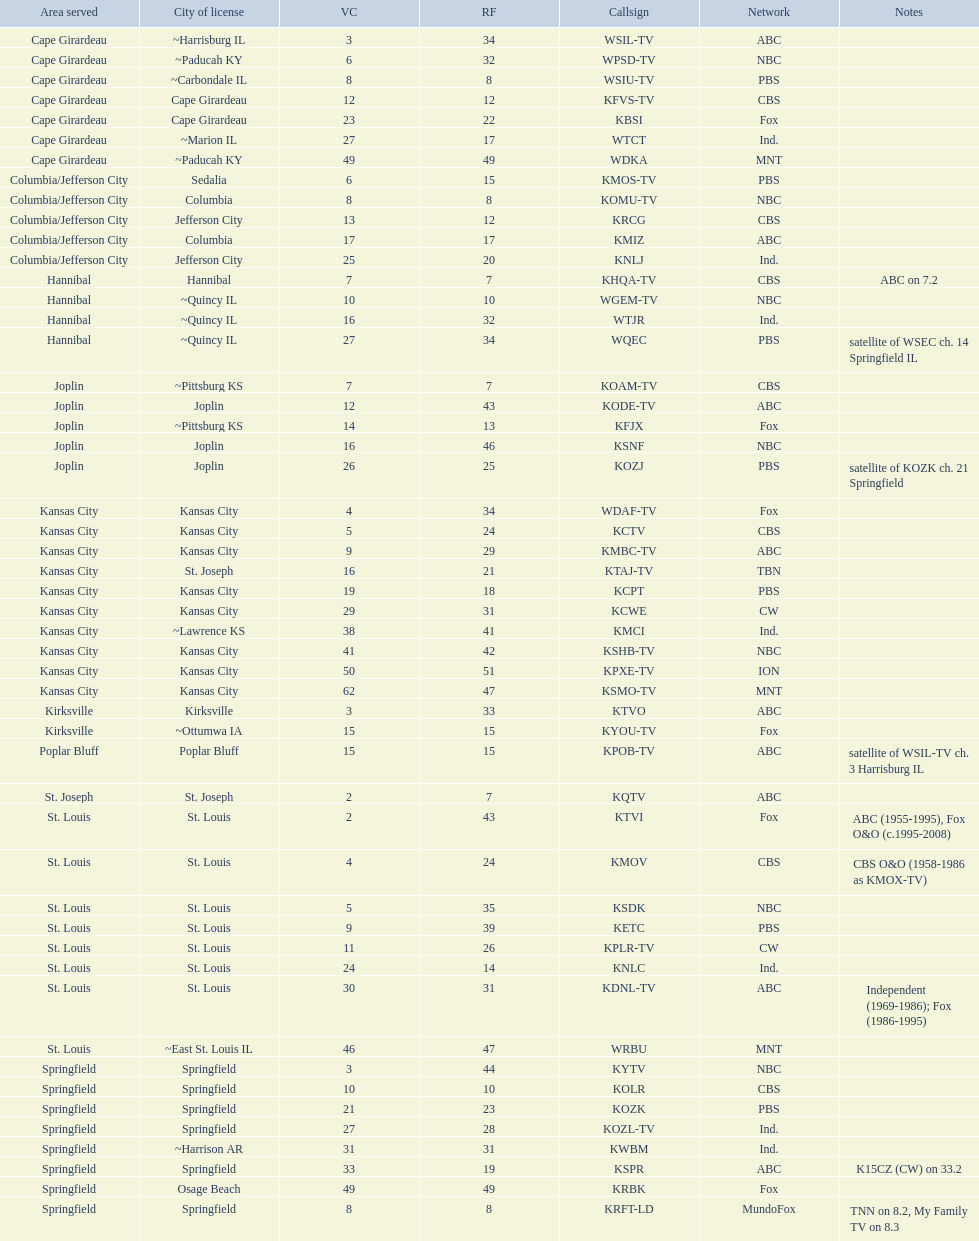Kode-tv and wsil-tv both belong to which broadcasting group? ABC. 